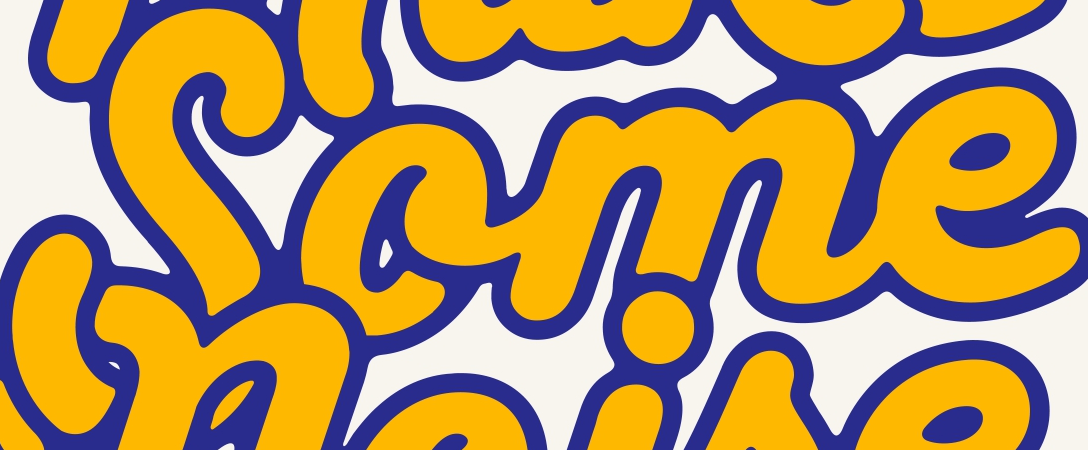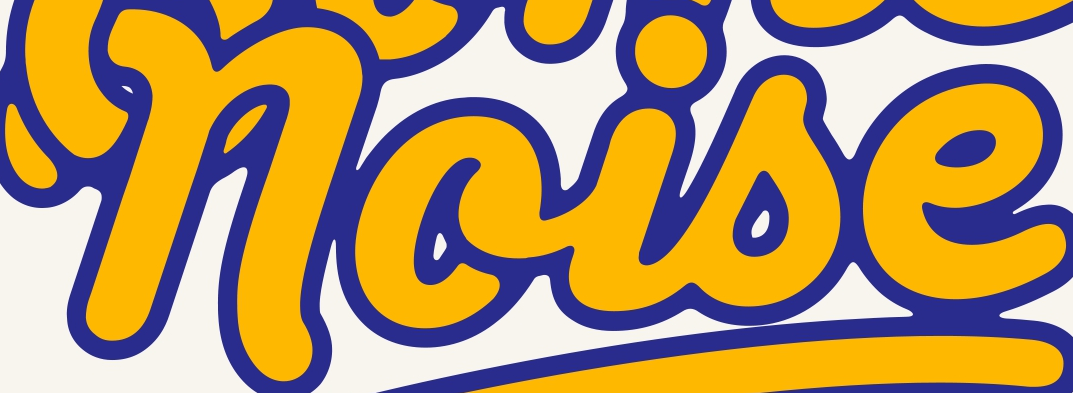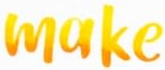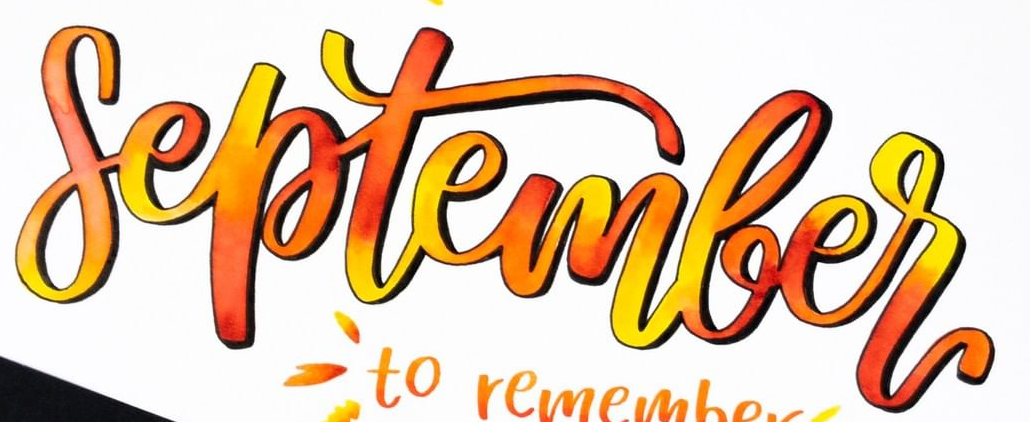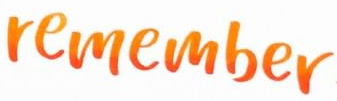What words can you see in these images in sequence, separated by a semicolon? Some; noise; make; September; remember 